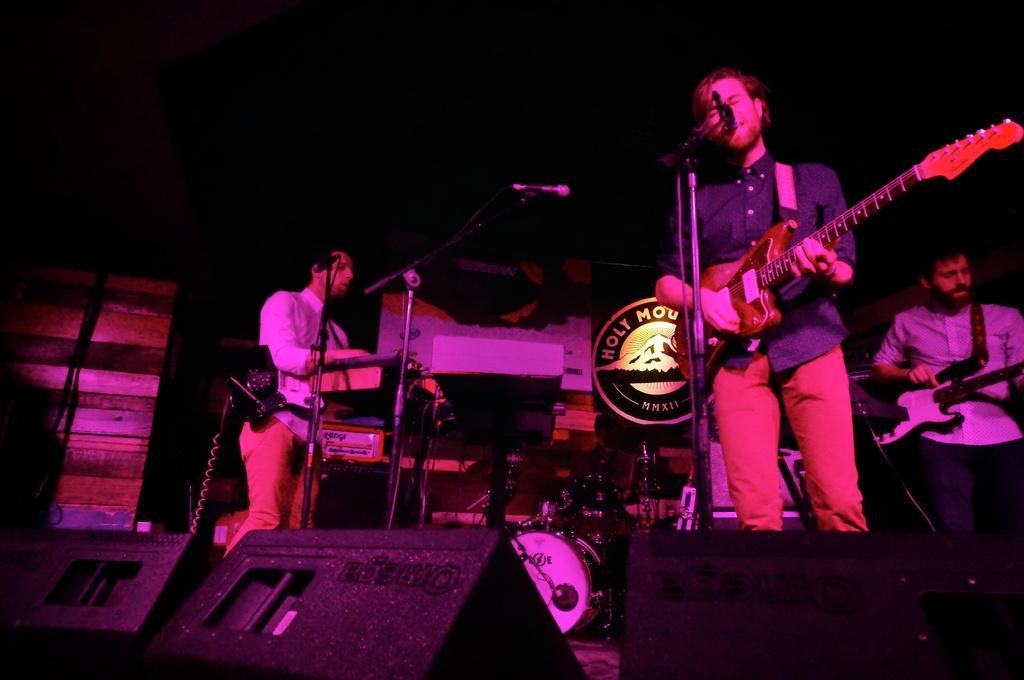How many people are in the image? There are three people in the image. What are the people doing in the image? The people are standing and singing. What are the people holding in their hands? The people are holding guitars in their hands. What type of fowl can be seen flying in the background of the image? There is no fowl visible in the image; it only features three people standing and singing while holding guitars. 